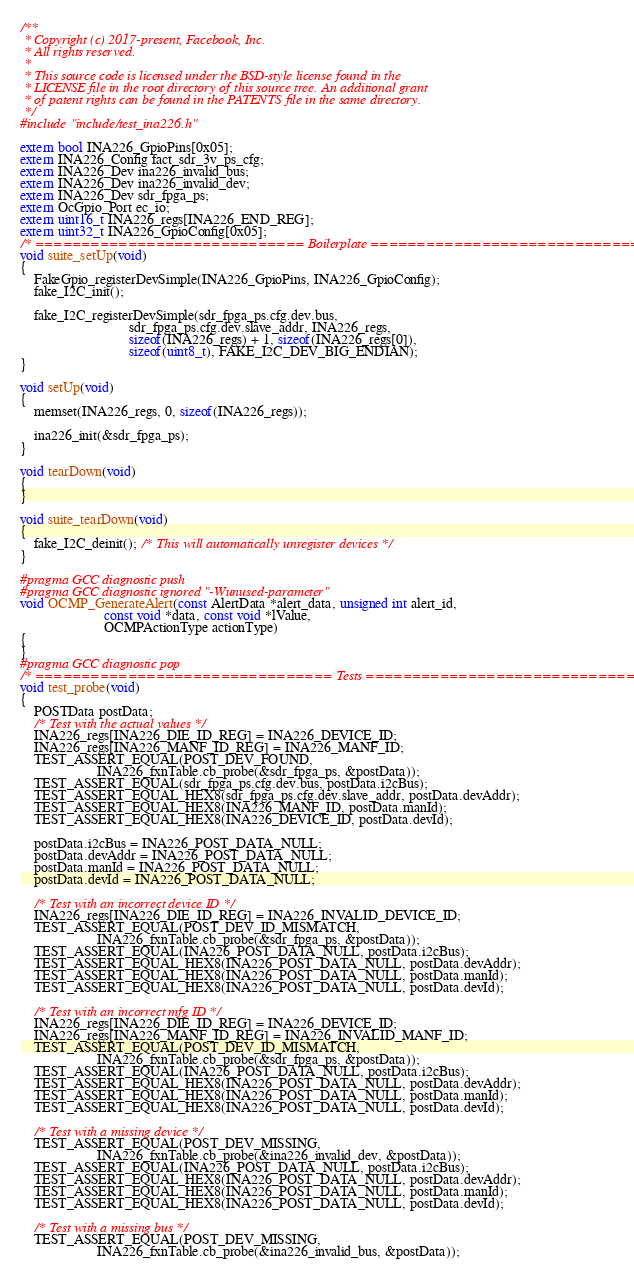Convert code to text. <code><loc_0><loc_0><loc_500><loc_500><_C_>/**
 * Copyright (c) 2017-present, Facebook, Inc.
 * All rights reserved.
 *
 * This source code is licensed under the BSD-style license found in the
 * LICENSE file in the root directory of this source tree. An additional grant
 * of patent rights can be found in the PATENTS file in the same directory.
 */
#include "include/test_ina226.h"

extern bool INA226_GpioPins[0x05];
extern INA226_Config fact_sdr_3v_ps_cfg;
extern INA226_Dev ina226_invalid_bus;
extern INA226_Dev ina226_invalid_dev;
extern INA226_Dev sdr_fpga_ps;
extern OcGpio_Port ec_io;
extern uint16_t INA226_regs[INA226_END_REG];
extern uint32_t INA226_GpioConfig[0x05];
/* ============================= Boilerplate ================================ */
void suite_setUp(void)
{
    FakeGpio_registerDevSimple(INA226_GpioPins, INA226_GpioConfig);
    fake_I2C_init();

    fake_I2C_registerDevSimple(sdr_fpga_ps.cfg.dev.bus,
                               sdr_fpga_ps.cfg.dev.slave_addr, INA226_regs,
                               sizeof(INA226_regs) + 1, sizeof(INA226_regs[0]),
                               sizeof(uint8_t), FAKE_I2C_DEV_BIG_ENDIAN);
}

void setUp(void)
{
    memset(INA226_regs, 0, sizeof(INA226_regs));

    ina226_init(&sdr_fpga_ps);
}

void tearDown(void)
{
}

void suite_tearDown(void)
{
    fake_I2C_deinit(); /* This will automatically unregister devices */
}

#pragma GCC diagnostic push
#pragma GCC diagnostic ignored "-Wunused-parameter"
void OCMP_GenerateAlert(const AlertData *alert_data, unsigned int alert_id,
                        const void *data, const void *lValue,
                        OCMPActionType actionType)
{
}
#pragma GCC diagnostic pop
/* ================================ Tests =================================== */
void test_probe(void)
{
    POSTData postData;
    /* Test with the actual values */
    INA226_regs[INA226_DIE_ID_REG] = INA226_DEVICE_ID;
    INA226_regs[INA226_MANF_ID_REG] = INA226_MANF_ID;
    TEST_ASSERT_EQUAL(POST_DEV_FOUND,
                      INA226_fxnTable.cb_probe(&sdr_fpga_ps, &postData));
    TEST_ASSERT_EQUAL(sdr_fpga_ps.cfg.dev.bus, postData.i2cBus);
    TEST_ASSERT_EQUAL_HEX8(sdr_fpga_ps.cfg.dev.slave_addr, postData.devAddr);
    TEST_ASSERT_EQUAL_HEX8(INA226_MANF_ID, postData.manId);
    TEST_ASSERT_EQUAL_HEX8(INA226_DEVICE_ID, postData.devId);

    postData.i2cBus = INA226_POST_DATA_NULL;
    postData.devAddr = INA226_POST_DATA_NULL;
    postData.manId = INA226_POST_DATA_NULL;
    postData.devId = INA226_POST_DATA_NULL;

    /* Test with an incorrect device ID */
    INA226_regs[INA226_DIE_ID_REG] = INA226_INVALID_DEVICE_ID;
    TEST_ASSERT_EQUAL(POST_DEV_ID_MISMATCH,
                      INA226_fxnTable.cb_probe(&sdr_fpga_ps, &postData));
    TEST_ASSERT_EQUAL(INA226_POST_DATA_NULL, postData.i2cBus);
    TEST_ASSERT_EQUAL_HEX8(INA226_POST_DATA_NULL, postData.devAddr);
    TEST_ASSERT_EQUAL_HEX8(INA226_POST_DATA_NULL, postData.manId);
    TEST_ASSERT_EQUAL_HEX8(INA226_POST_DATA_NULL, postData.devId);

    /* Test with an incorrect mfg ID */
    INA226_regs[INA226_DIE_ID_REG] = INA226_DEVICE_ID;
    INA226_regs[INA226_MANF_ID_REG] = INA226_INVALID_MANF_ID;
    TEST_ASSERT_EQUAL(POST_DEV_ID_MISMATCH,
                      INA226_fxnTable.cb_probe(&sdr_fpga_ps, &postData));
    TEST_ASSERT_EQUAL(INA226_POST_DATA_NULL, postData.i2cBus);
    TEST_ASSERT_EQUAL_HEX8(INA226_POST_DATA_NULL, postData.devAddr);
    TEST_ASSERT_EQUAL_HEX8(INA226_POST_DATA_NULL, postData.manId);
    TEST_ASSERT_EQUAL_HEX8(INA226_POST_DATA_NULL, postData.devId);

    /* Test with a missing device */
    TEST_ASSERT_EQUAL(POST_DEV_MISSING,
                      INA226_fxnTable.cb_probe(&ina226_invalid_dev, &postData));
    TEST_ASSERT_EQUAL(INA226_POST_DATA_NULL, postData.i2cBus);
    TEST_ASSERT_EQUAL_HEX8(INA226_POST_DATA_NULL, postData.devAddr);
    TEST_ASSERT_EQUAL_HEX8(INA226_POST_DATA_NULL, postData.manId);
    TEST_ASSERT_EQUAL_HEX8(INA226_POST_DATA_NULL, postData.devId);

    /* Test with a missing bus */
    TEST_ASSERT_EQUAL(POST_DEV_MISSING,
                      INA226_fxnTable.cb_probe(&ina226_invalid_bus, &postData));</code> 